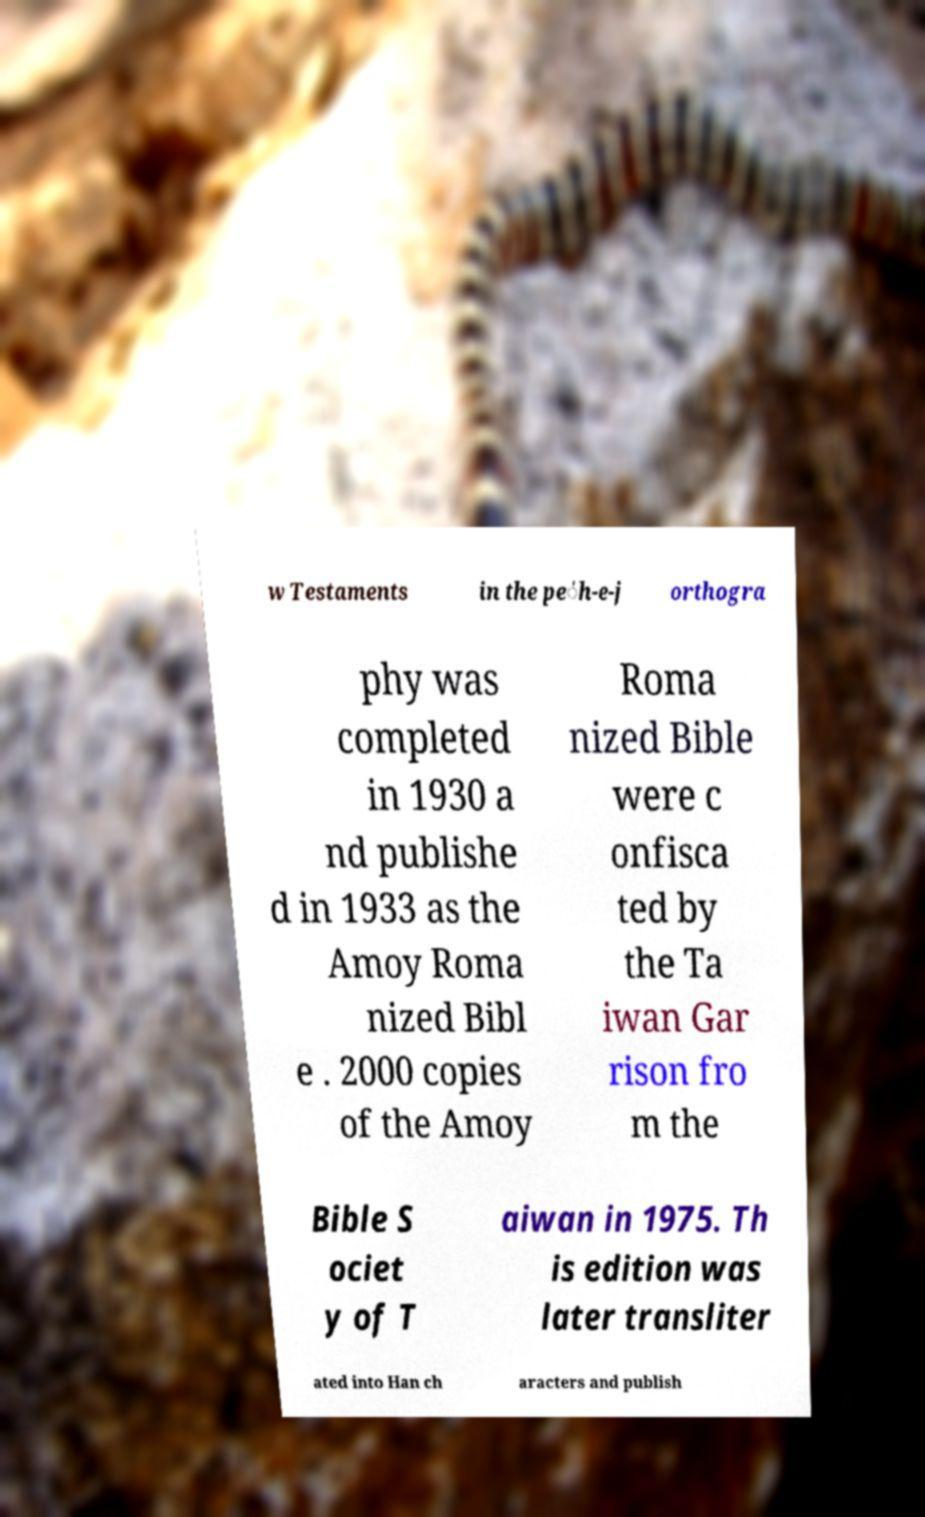Can you accurately transcribe the text from the provided image for me? w Testaments in the pe̍h-e-j orthogra phy was completed in 1930 a nd publishe d in 1933 as the Amoy Roma nized Bibl e . 2000 copies of the Amoy Roma nized Bible were c onfisca ted by the Ta iwan Gar rison fro m the Bible S ociet y of T aiwan in 1975. Th is edition was later transliter ated into Han ch aracters and publish 